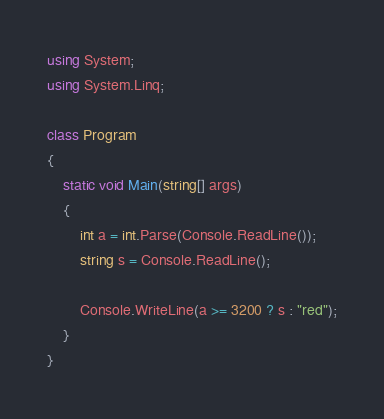<code> <loc_0><loc_0><loc_500><loc_500><_C#_>using System;
using System.Linq;

class Program
{
    static void Main(string[] args)
    {
		int a = int.Parse(Console.ReadLine());
		string s = Console.ReadLine();

		Console.WriteLine(a >= 3200 ? s : "red");
	}
}
</code> 